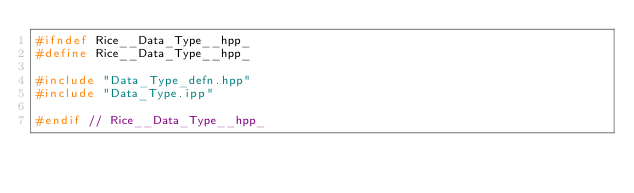<code> <loc_0><loc_0><loc_500><loc_500><_C++_>#ifndef Rice__Data_Type__hpp_
#define Rice__Data_Type__hpp_

#include "Data_Type_defn.hpp"
#include "Data_Type.ipp"

#endif // Rice__Data_Type__hpp_

</code> 